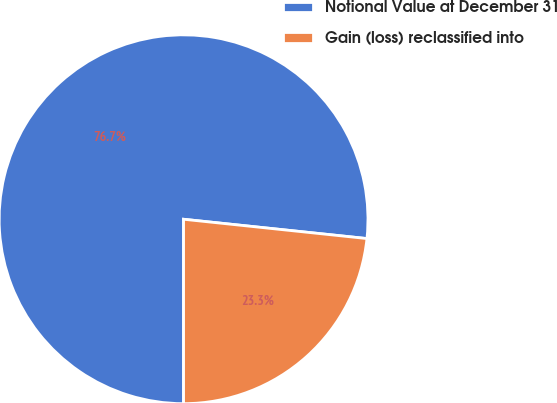<chart> <loc_0><loc_0><loc_500><loc_500><pie_chart><fcel>Notional Value at December 31<fcel>Gain (loss) reclassified into<nl><fcel>76.67%<fcel>23.33%<nl></chart> 